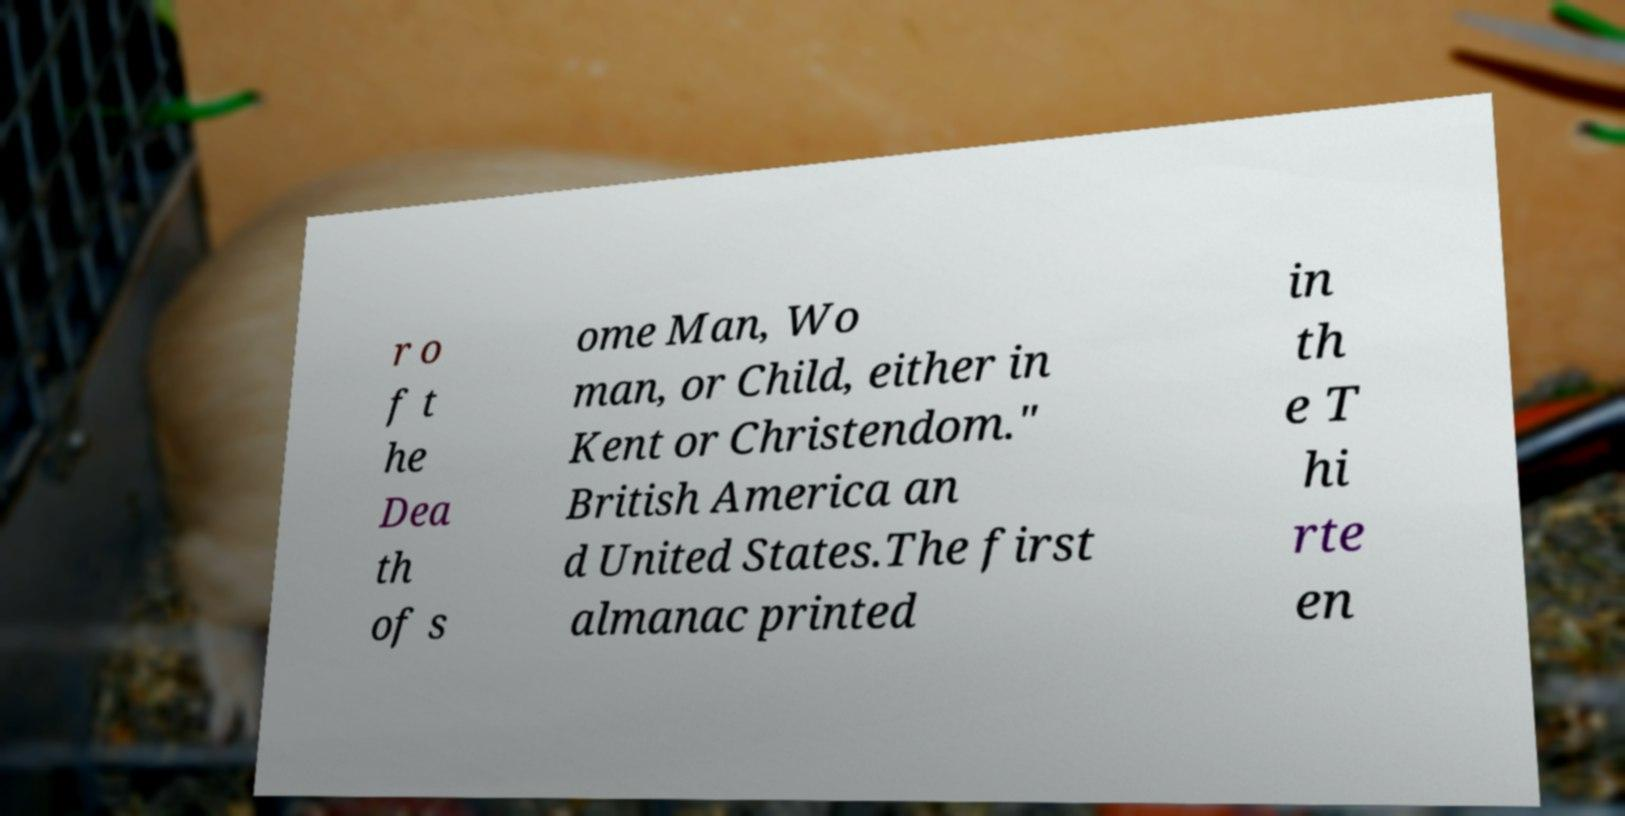Please read and relay the text visible in this image. What does it say? r o f t he Dea th of s ome Man, Wo man, or Child, either in Kent or Christendom." British America an d United States.The first almanac printed in th e T hi rte en 